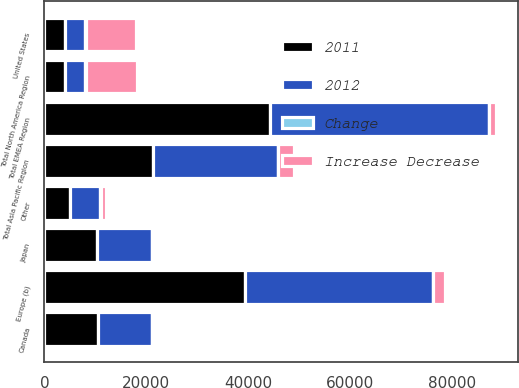Convert chart. <chart><loc_0><loc_0><loc_500><loc_500><stacked_bar_chart><ecel><fcel>United States<fcel>Canada<fcel>Total North America Region<fcel>Europe (b)<fcel>Other<fcel>Total EMEA Region<fcel>Japan<fcel>Total Asia Pacific Region<nl><fcel>2012<fcel>4035.5<fcel>10573<fcel>4035.5<fcel>37027<fcel>6000<fcel>43027<fcel>10642<fcel>24481<nl><fcel>2011<fcel>4035.5<fcel>10502<fcel>4035.5<fcel>39334<fcel>5006<fcel>44340<fcel>10401<fcel>21416<nl><fcel>Increase Decrease<fcel>9995<fcel>71<fcel>10066<fcel>2307<fcel>994<fcel>1313<fcel>241<fcel>3065<nl><fcel>Change<fcel>6.6<fcel>0.7<fcel>6.2<fcel>5.9<fcel>19.9<fcel>3<fcel>2.3<fcel>14.3<nl></chart> 